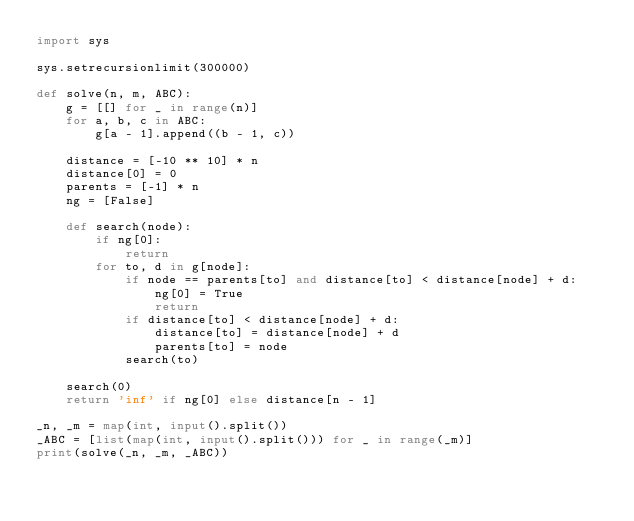Convert code to text. <code><loc_0><loc_0><loc_500><loc_500><_Python_>import sys

sys.setrecursionlimit(300000)

def solve(n, m, ABC):
    g = [[] for _ in range(n)]
    for a, b, c in ABC:
        g[a - 1].append((b - 1, c))

    distance = [-10 ** 10] * n
    distance[0] = 0
    parents = [-1] * n
    ng = [False]

    def search(node):
        if ng[0]:
            return
        for to, d in g[node]:
            if node == parents[to] and distance[to] < distance[node] + d:
                ng[0] = True
                return
            if distance[to] < distance[node] + d:
                distance[to] = distance[node] + d
                parents[to] = node
            search(to)

    search(0)
    return 'inf' if ng[0] else distance[n - 1]

_n, _m = map(int, input().split())
_ABC = [list(map(int, input().split())) for _ in range(_m)]
print(solve(_n, _m, _ABC))
</code> 